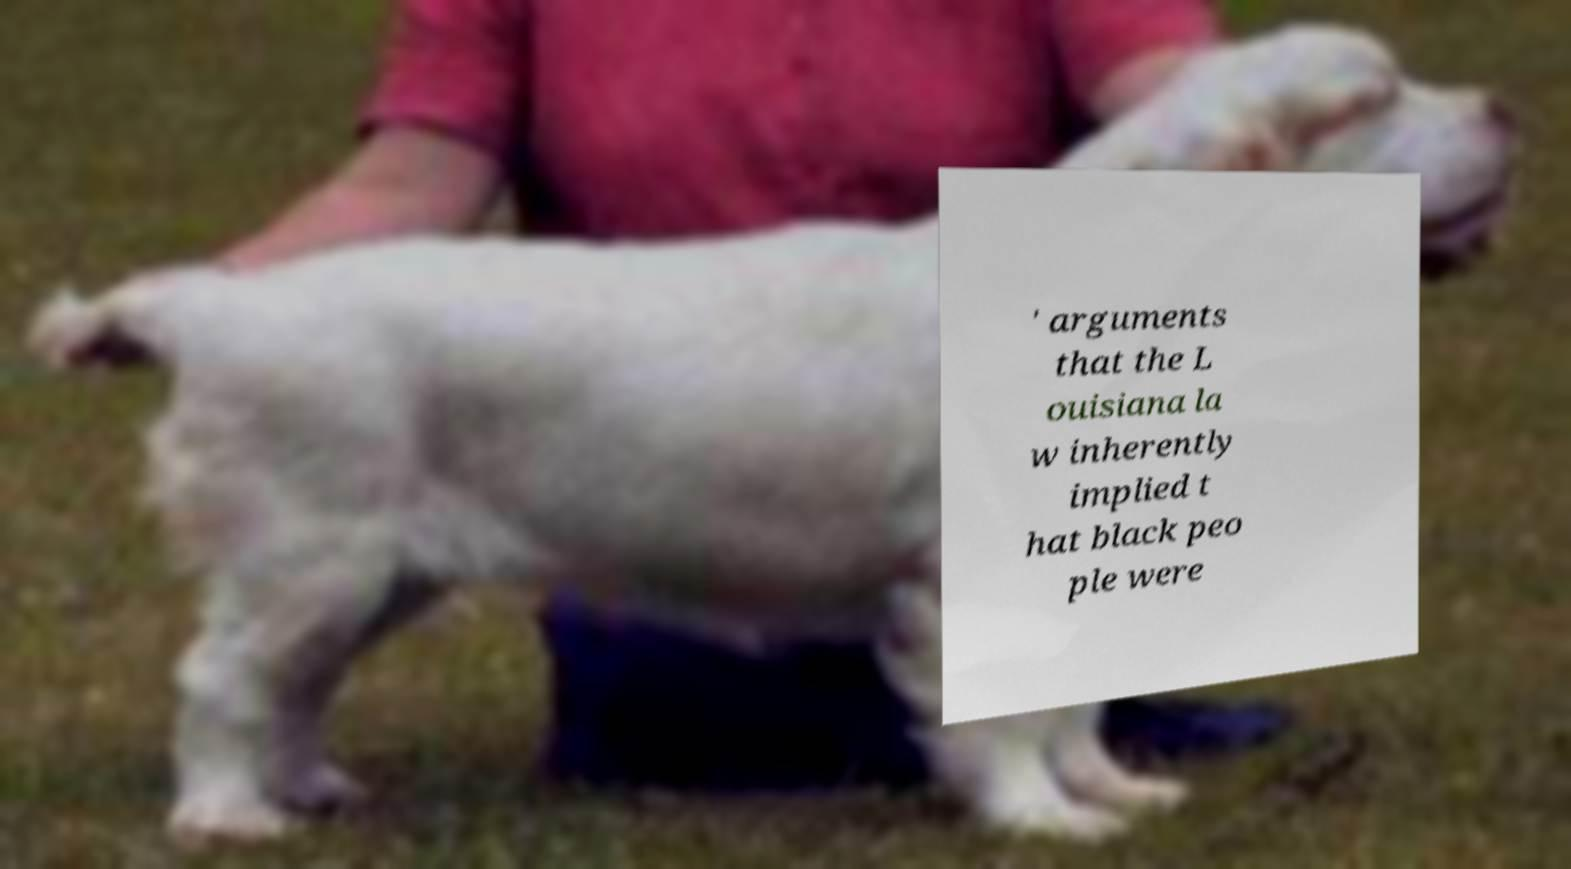There's text embedded in this image that I need extracted. Can you transcribe it verbatim? ' arguments that the L ouisiana la w inherently implied t hat black peo ple were 